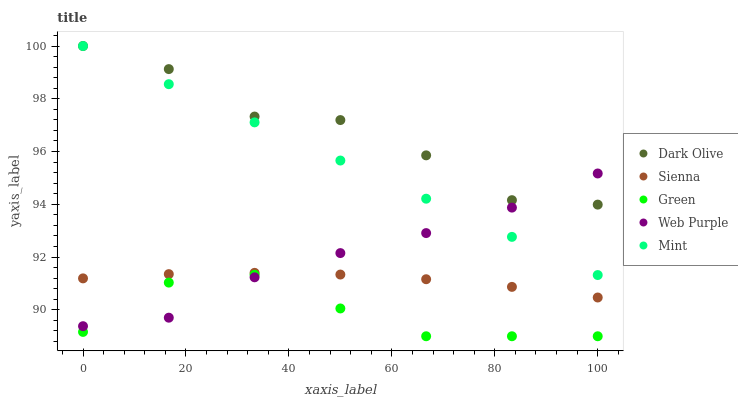Does Green have the minimum area under the curve?
Answer yes or no. Yes. Does Dark Olive have the maximum area under the curve?
Answer yes or no. Yes. Does Mint have the minimum area under the curve?
Answer yes or no. No. Does Mint have the maximum area under the curve?
Answer yes or no. No. Is Mint the smoothest?
Answer yes or no. Yes. Is Dark Olive the roughest?
Answer yes or no. Yes. Is Web Purple the smoothest?
Answer yes or no. No. Is Web Purple the roughest?
Answer yes or no. No. Does Green have the lowest value?
Answer yes or no. Yes. Does Mint have the lowest value?
Answer yes or no. No. Does Dark Olive have the highest value?
Answer yes or no. Yes. Does Web Purple have the highest value?
Answer yes or no. No. Is Green less than Mint?
Answer yes or no. Yes. Is Dark Olive greater than Sienna?
Answer yes or no. Yes. Does Web Purple intersect Green?
Answer yes or no. Yes. Is Web Purple less than Green?
Answer yes or no. No. Is Web Purple greater than Green?
Answer yes or no. No. Does Green intersect Mint?
Answer yes or no. No. 